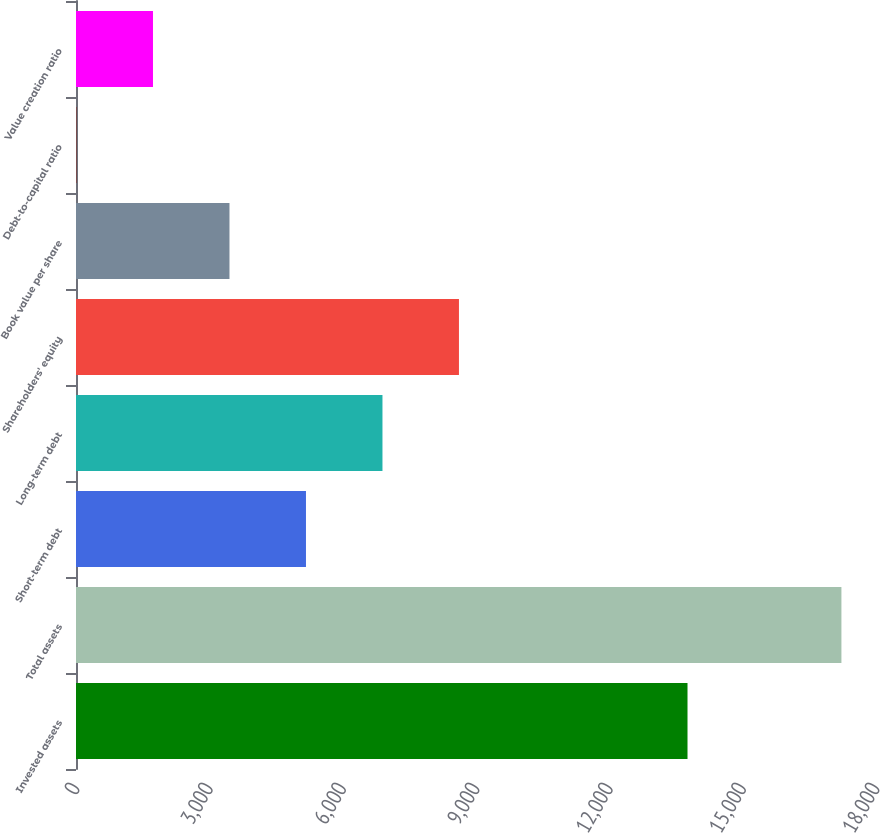Convert chart. <chart><loc_0><loc_0><loc_500><loc_500><bar_chart><fcel>Invested assets<fcel>Total assets<fcel>Short-term debt<fcel>Long-term debt<fcel>Shareholders' equity<fcel>Book value per share<fcel>Debt-to-capital ratio<fcel>Value creation ratio<nl><fcel>13759<fcel>17222<fcel>5174.3<fcel>6895.4<fcel>8616.5<fcel>3453.2<fcel>11<fcel>1732.1<nl></chart> 